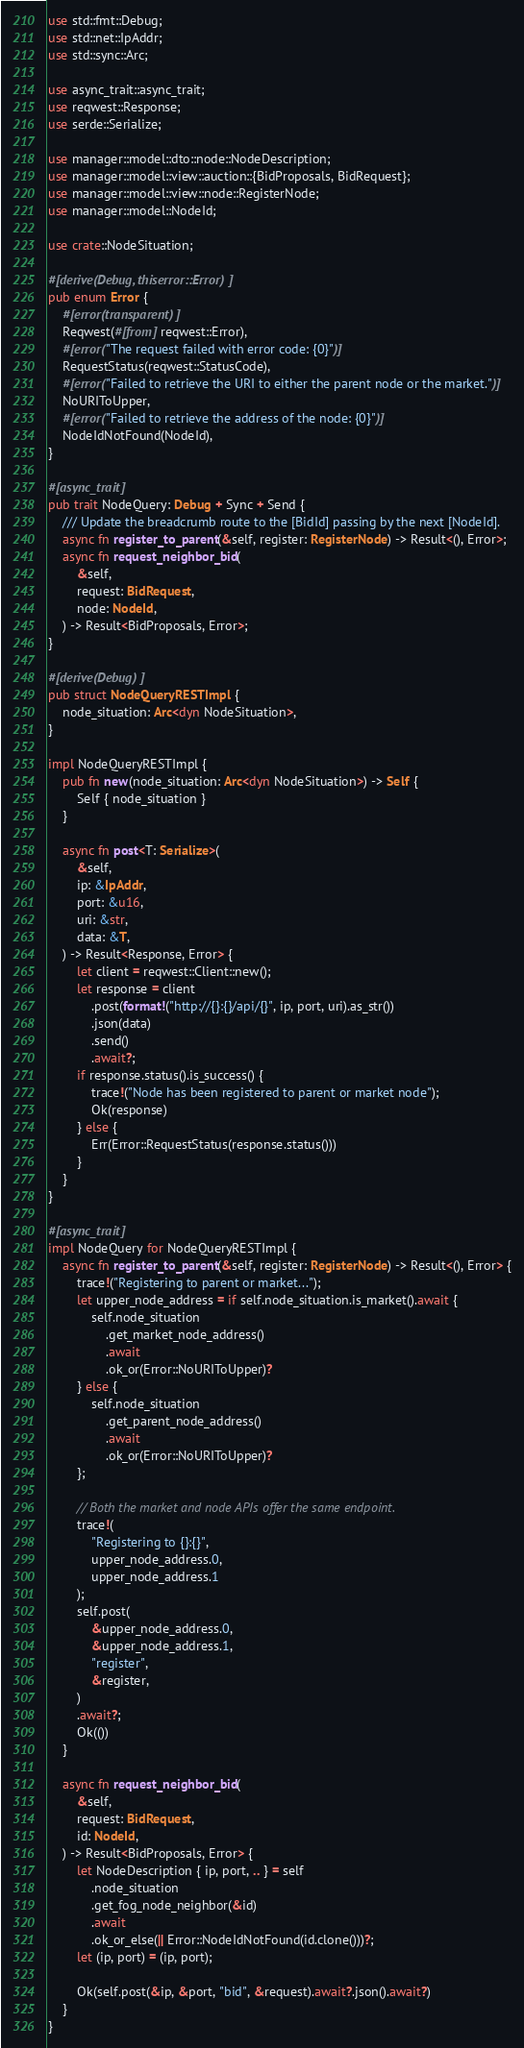Convert code to text. <code><loc_0><loc_0><loc_500><loc_500><_Rust_>use std::fmt::Debug;
use std::net::IpAddr;
use std::sync::Arc;

use async_trait::async_trait;
use reqwest::Response;
use serde::Serialize;

use manager::model::dto::node::NodeDescription;
use manager::model::view::auction::{BidProposals, BidRequest};
use manager::model::view::node::RegisterNode;
use manager::model::NodeId;

use crate::NodeSituation;

#[derive(Debug, thiserror::Error)]
pub enum Error {
    #[error(transparent)]
    Reqwest(#[from] reqwest::Error),
    #[error("The request failed with error code: {0}")]
    RequestStatus(reqwest::StatusCode),
    #[error("Failed to retrieve the URI to either the parent node or the market.")]
    NoURIToUpper,
    #[error("Failed to retrieve the address of the node: {0}")]
    NodeIdNotFound(NodeId),
}

#[async_trait]
pub trait NodeQuery: Debug + Sync + Send {
    /// Update the breadcrumb route to the [BidId] passing by the next [NodeId].
    async fn register_to_parent(&self, register: RegisterNode) -> Result<(), Error>;
    async fn request_neighbor_bid(
        &self,
        request: BidRequest,
        node: NodeId,
    ) -> Result<BidProposals, Error>;
}

#[derive(Debug)]
pub struct NodeQueryRESTImpl {
    node_situation: Arc<dyn NodeSituation>,
}

impl NodeQueryRESTImpl {
    pub fn new(node_situation: Arc<dyn NodeSituation>) -> Self {
        Self { node_situation }
    }

    async fn post<T: Serialize>(
        &self,
        ip: &IpAddr,
        port: &u16,
        uri: &str,
        data: &T,
    ) -> Result<Response, Error> {
        let client = reqwest::Client::new();
        let response = client
            .post(format!("http://{}:{}/api/{}", ip, port, uri).as_str())
            .json(data)
            .send()
            .await?;
        if response.status().is_success() {
            trace!("Node has been registered to parent or market node");
            Ok(response)
        } else {
            Err(Error::RequestStatus(response.status()))
        }
    }
}

#[async_trait]
impl NodeQuery for NodeQueryRESTImpl {
    async fn register_to_parent(&self, register: RegisterNode) -> Result<(), Error> {
        trace!("Registering to parent or market...");
        let upper_node_address = if self.node_situation.is_market().await {
            self.node_situation
                .get_market_node_address()
                .await
                .ok_or(Error::NoURIToUpper)?
        } else {
            self.node_situation
                .get_parent_node_address()
                .await
                .ok_or(Error::NoURIToUpper)?
        };

        // Both the market and node APIs offer the same endpoint.
        trace!(
            "Registering to {}:{}",
            upper_node_address.0,
            upper_node_address.1
        );
        self.post(
            &upper_node_address.0,
            &upper_node_address.1,
            "register",
            &register,
        )
        .await?;
        Ok(())
    }

    async fn request_neighbor_bid(
        &self,
        request: BidRequest,
        id: NodeId,
    ) -> Result<BidProposals, Error> {
        let NodeDescription { ip, port, .. } = self
            .node_situation
            .get_fog_node_neighbor(&id)
            .await
            .ok_or_else(|| Error::NodeIdNotFound(id.clone()))?;
        let (ip, port) = (ip, port);

        Ok(self.post(&ip, &port, "bid", &request).await?.json().await?)
    }
}
</code> 